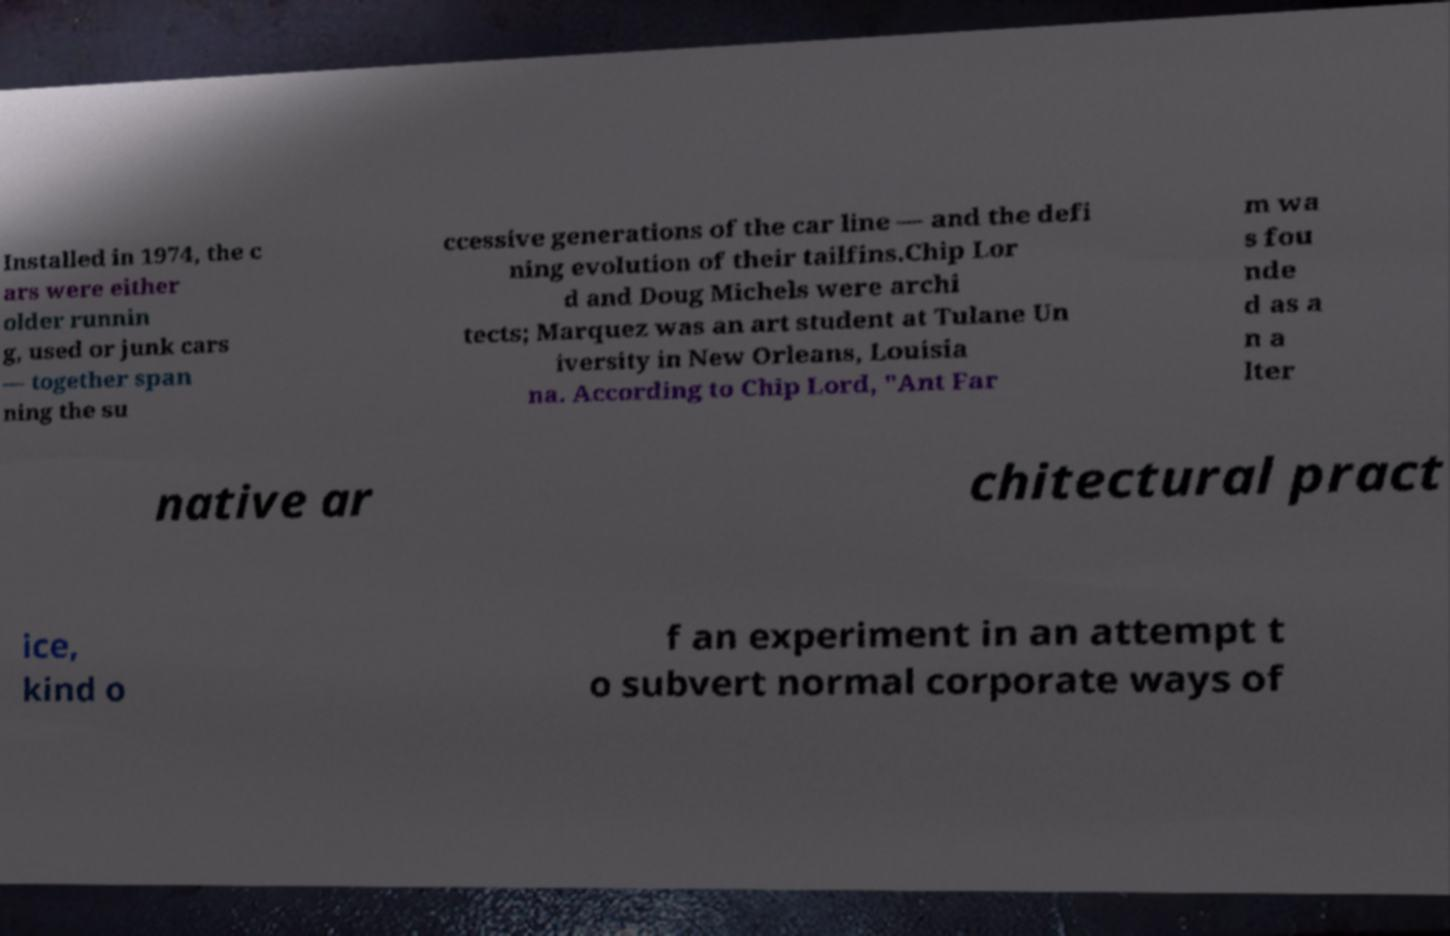There's text embedded in this image that I need extracted. Can you transcribe it verbatim? Installed in 1974, the c ars were either older runnin g, used or junk cars — together span ning the su ccessive generations of the car line — and the defi ning evolution of their tailfins.Chip Lor d and Doug Michels were archi tects; Marquez was an art student at Tulane Un iversity in New Orleans, Louisia na. According to Chip Lord, "Ant Far m wa s fou nde d as a n a lter native ar chitectural pract ice, kind o f an experiment in an attempt t o subvert normal corporate ways of 